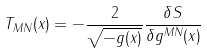<formula> <loc_0><loc_0><loc_500><loc_500>T _ { M N } ( x ) = - \frac { 2 } { \sqrt { - g ( x ) } } \frac { \delta S } { \delta g ^ { M N } ( x ) }</formula> 